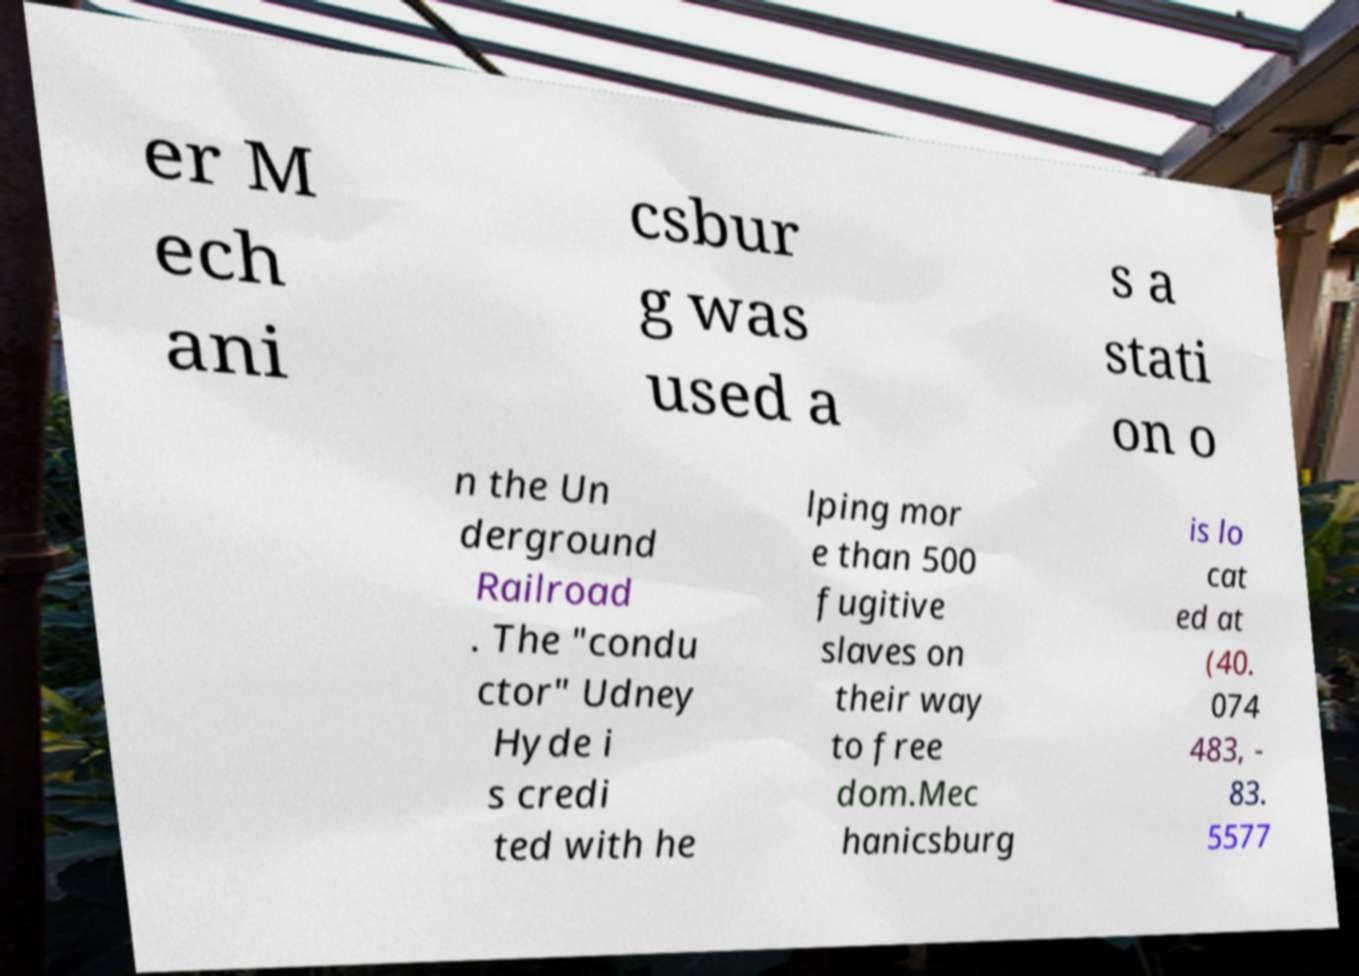Can you read and provide the text displayed in the image?This photo seems to have some interesting text. Can you extract and type it out for me? er M ech ani csbur g was used a s a stati on o n the Un derground Railroad . The "condu ctor" Udney Hyde i s credi ted with he lping mor e than 500 fugitive slaves on their way to free dom.Mec hanicsburg is lo cat ed at (40. 074 483, - 83. 5577 